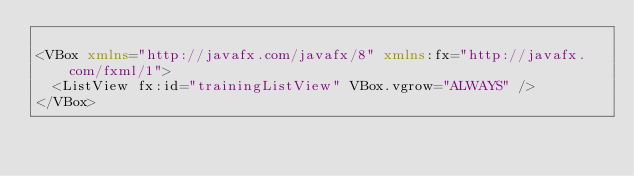<code> <loc_0><loc_0><loc_500><loc_500><_XML_>
<VBox xmlns="http://javafx.com/javafx/8" xmlns:fx="http://javafx.com/fxml/1">
  <ListView fx:id="trainingListView" VBox.vgrow="ALWAYS" />
</VBox>
</code> 